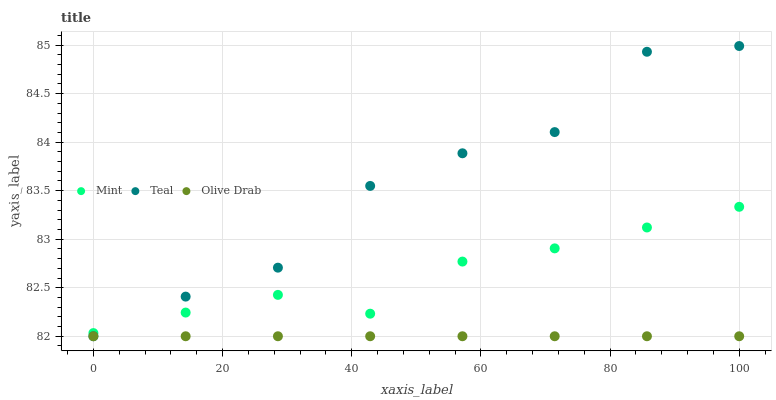Does Olive Drab have the minimum area under the curve?
Answer yes or no. Yes. Does Teal have the maximum area under the curve?
Answer yes or no. Yes. Does Teal have the minimum area under the curve?
Answer yes or no. No. Does Olive Drab have the maximum area under the curve?
Answer yes or no. No. Is Olive Drab the smoothest?
Answer yes or no. Yes. Is Teal the roughest?
Answer yes or no. Yes. Is Teal the smoothest?
Answer yes or no. No. Is Olive Drab the roughest?
Answer yes or no. No. Does Olive Drab have the lowest value?
Answer yes or no. Yes. Does Teal have the highest value?
Answer yes or no. Yes. Does Olive Drab have the highest value?
Answer yes or no. No. Is Olive Drab less than Mint?
Answer yes or no. Yes. Is Mint greater than Olive Drab?
Answer yes or no. Yes. Does Teal intersect Olive Drab?
Answer yes or no. Yes. Is Teal less than Olive Drab?
Answer yes or no. No. Is Teal greater than Olive Drab?
Answer yes or no. No. Does Olive Drab intersect Mint?
Answer yes or no. No. 